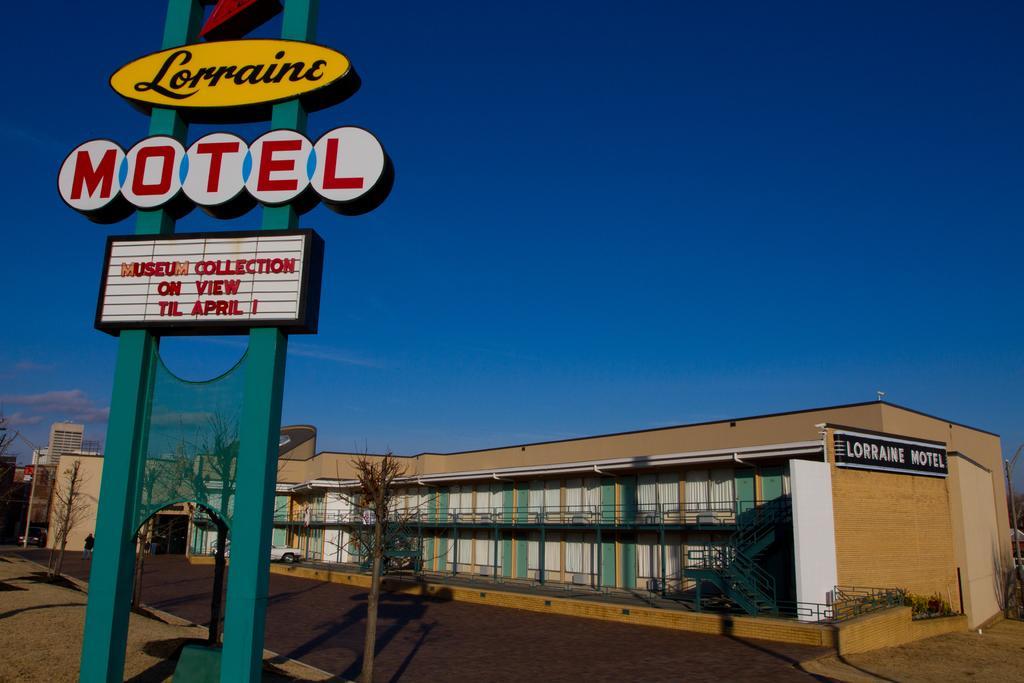In one or two sentences, can you explain what this image depicts? In this picture I can see buildings, there are vehicles on the road, there are birds, there are trees, and in the background there is the sky. 